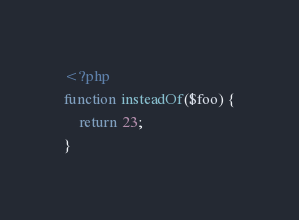<code> <loc_0><loc_0><loc_500><loc_500><_PHP_><?php
function insteadOf($foo) {
    return 23;
}
</code> 